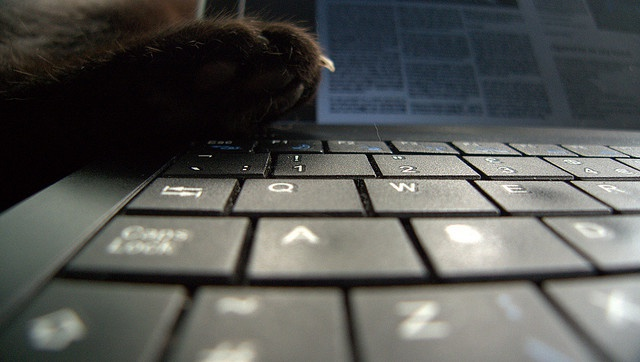Describe the objects in this image and their specific colors. I can see laptop in black, darkgray, and gray tones, keyboard in black, darkgray, and gray tones, and cat in black and gray tones in this image. 